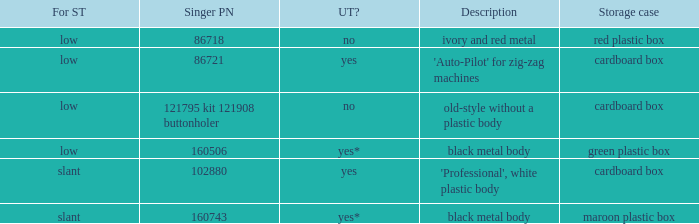What's the storage case of the buttonholer described as ivory and red metal? Red plastic box. 